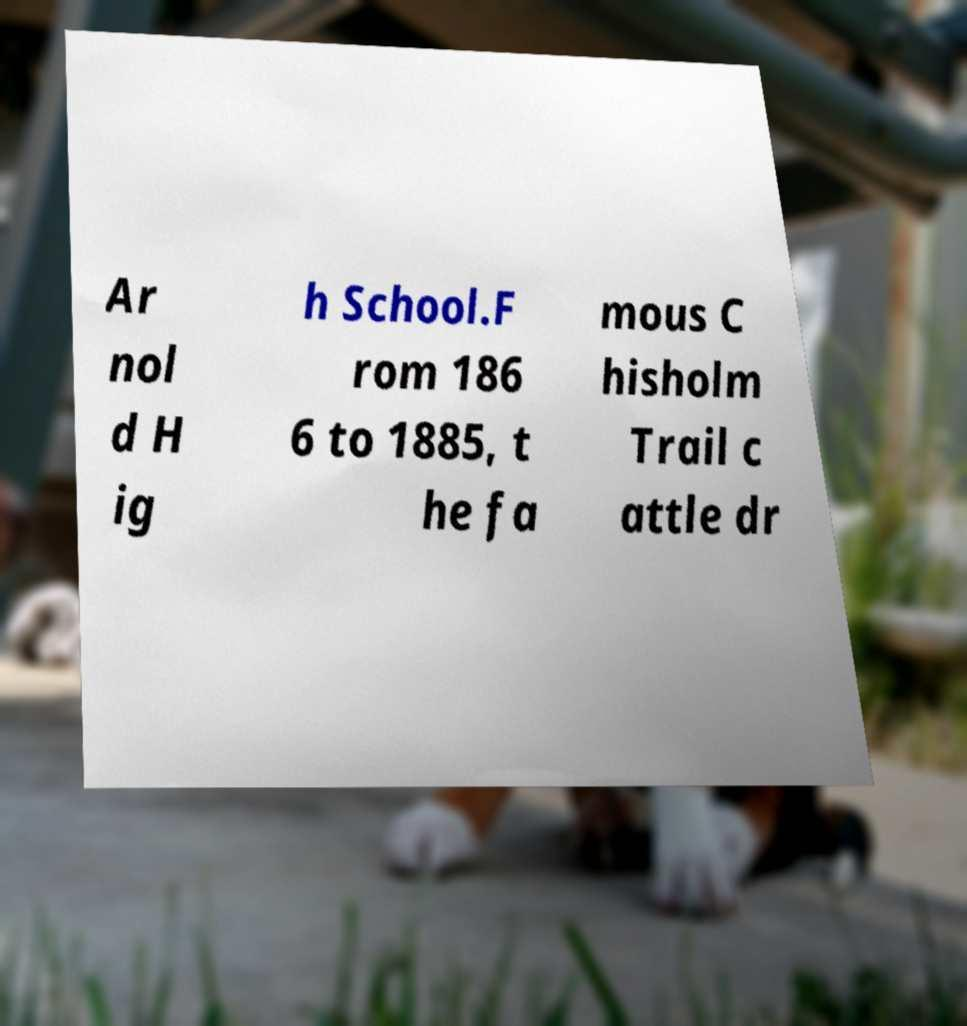Please read and relay the text visible in this image. What does it say? Ar nol d H ig h School.F rom 186 6 to 1885, t he fa mous C hisholm Trail c attle dr 